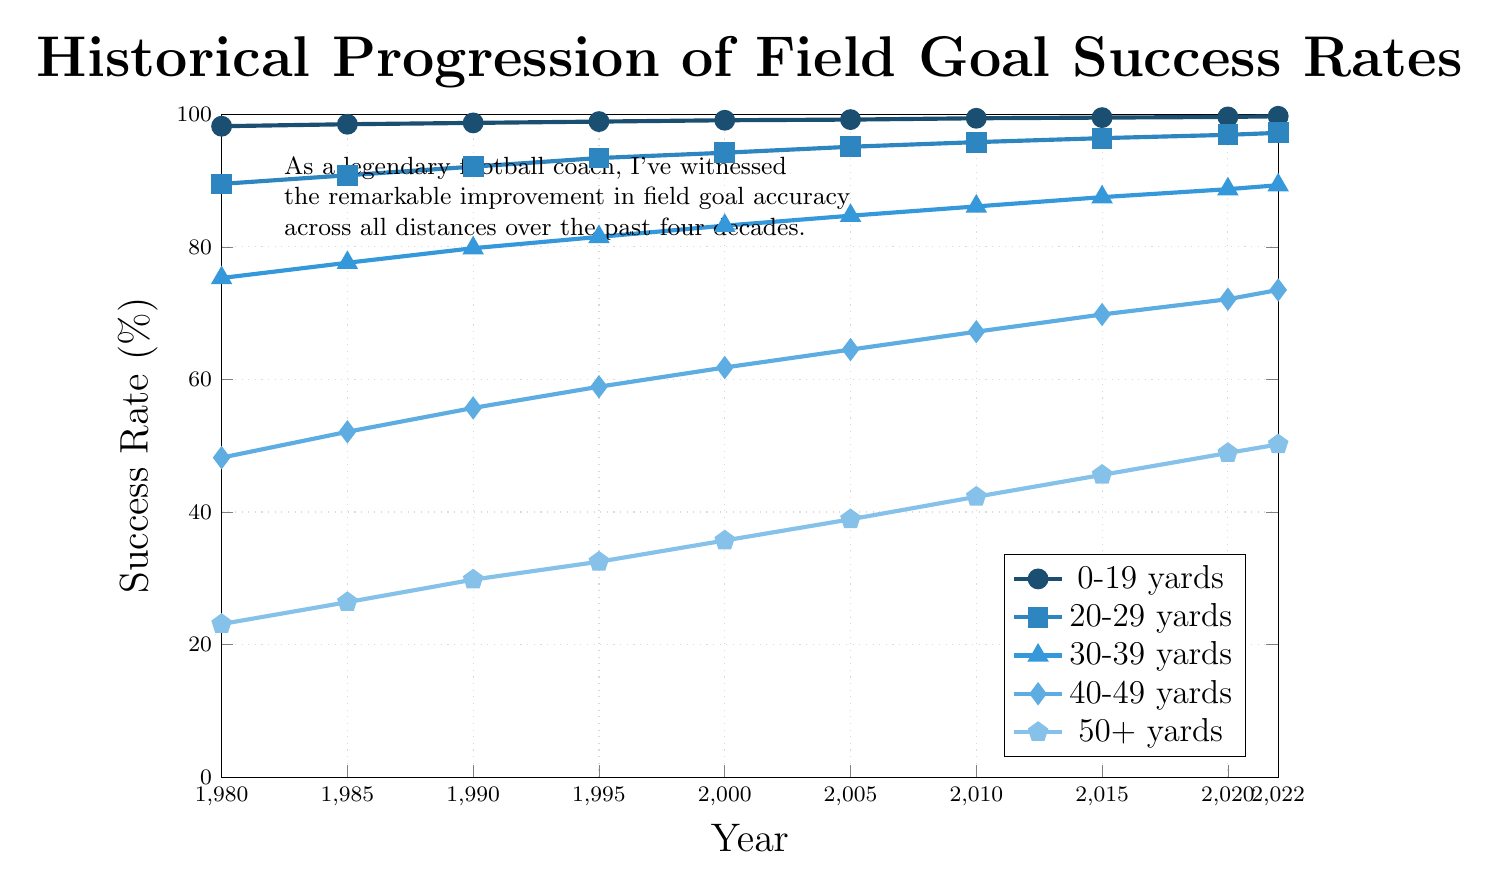How has the success rate of field goals from 30-39 yards changed from 1980 to 2022? To answer this, compare the success rate of field goals from 30-39 yards in 1980 and 2022. In 1980, the success rate was 75.3%. By 2022, it increased to 89.3%. Calculate the difference: 89.3% - 75.3% = 14%.
Answer: 14% What is the trend in the success rate of field goals from 0-19 yards over the years? Examine the line representing the 0-19 yard range. The success rate starts at 98.2% in 1980 and gradually increases till 2022, where it reaches 99.7%. This indicates a slight but consistent improvement every few years.
Answer: Increasing trend How does the success rate of field goals from 20-29 yards in 1990 compare to those from 40-49 yards in the same year? Look at 1990's data for both 20-29 yards and 40-49 yards. The success rates are 92.1% for 20-29 yards and 55.7% for 40-49 yards. A simple comparison shows that success rates for 20-29 yards are significantly higher than those for 40-49 yards.
Answer: Higher 